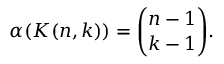Convert formula to latex. <formula><loc_0><loc_0><loc_500><loc_500>\alpha ( K ( n , k ) ) = { \binom { n - 1 } { k - 1 } } .</formula> 